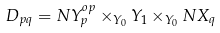Convert formula to latex. <formula><loc_0><loc_0><loc_500><loc_500>D _ { p q } = N Y ^ { o p } _ { p } \times _ { Y _ { 0 } } Y _ { 1 } \times _ { Y _ { 0 } } N X _ { q }</formula> 